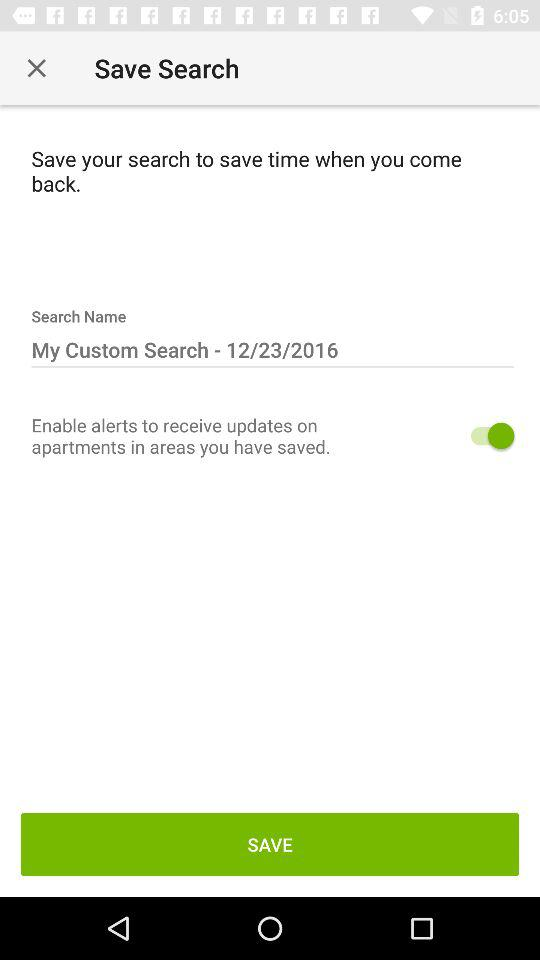What is the status of "Enable alerts to receive updates on apartments in areas you have saved."? The status is "on". 